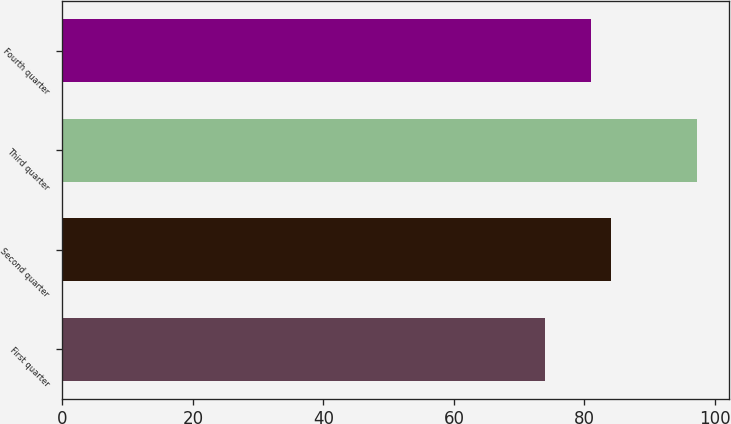Convert chart to OTSL. <chart><loc_0><loc_0><loc_500><loc_500><bar_chart><fcel>First quarter<fcel>Second quarter<fcel>Third quarter<fcel>Fourth quarter<nl><fcel>73.96<fcel>84.13<fcel>97.24<fcel>80.93<nl></chart> 